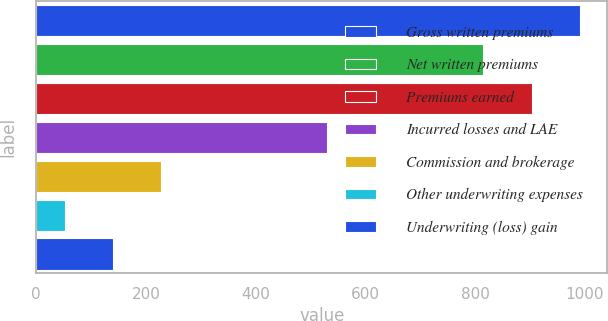<chart> <loc_0><loc_0><loc_500><loc_500><bar_chart><fcel>Gross written premiums<fcel>Net written premiums<fcel>Premiums earned<fcel>Incurred losses and LAE<fcel>Commission and brokerage<fcel>Other underwriting expenses<fcel>Underwriting (loss) gain<nl><fcel>991.42<fcel>815.3<fcel>903.36<fcel>530.8<fcel>228.02<fcel>51.9<fcel>139.96<nl></chart> 